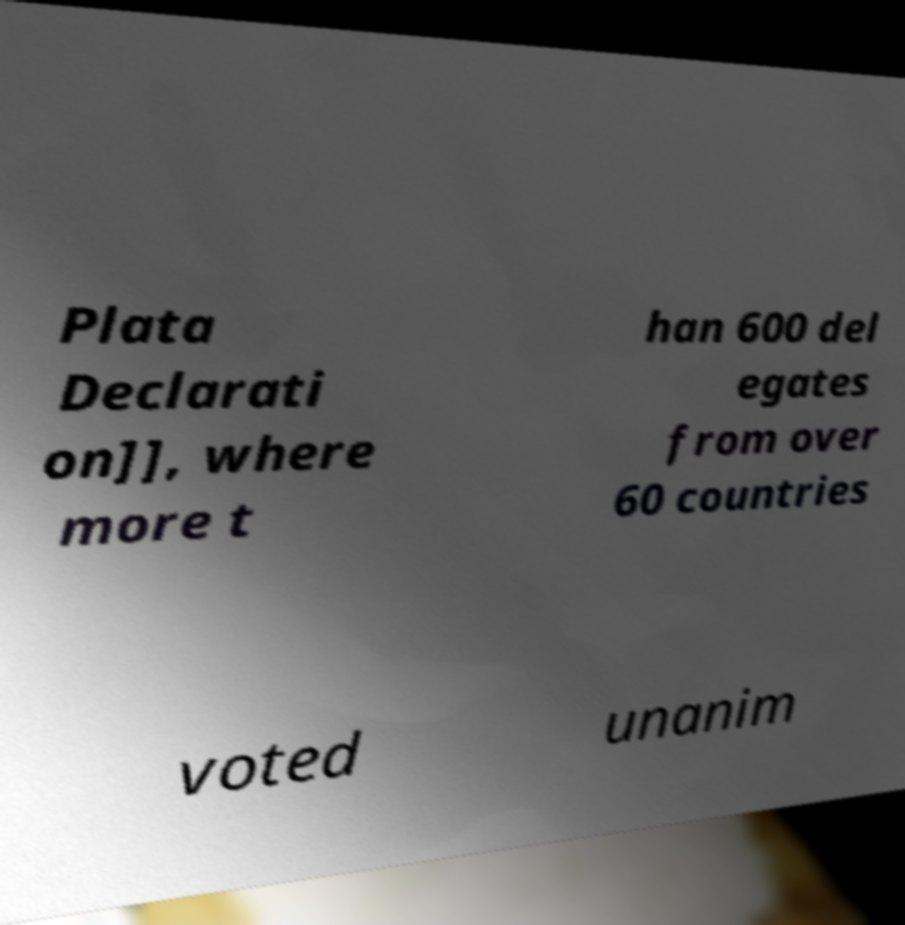Please read and relay the text visible in this image. What does it say? Plata Declarati on]], where more t han 600 del egates from over 60 countries voted unanim 